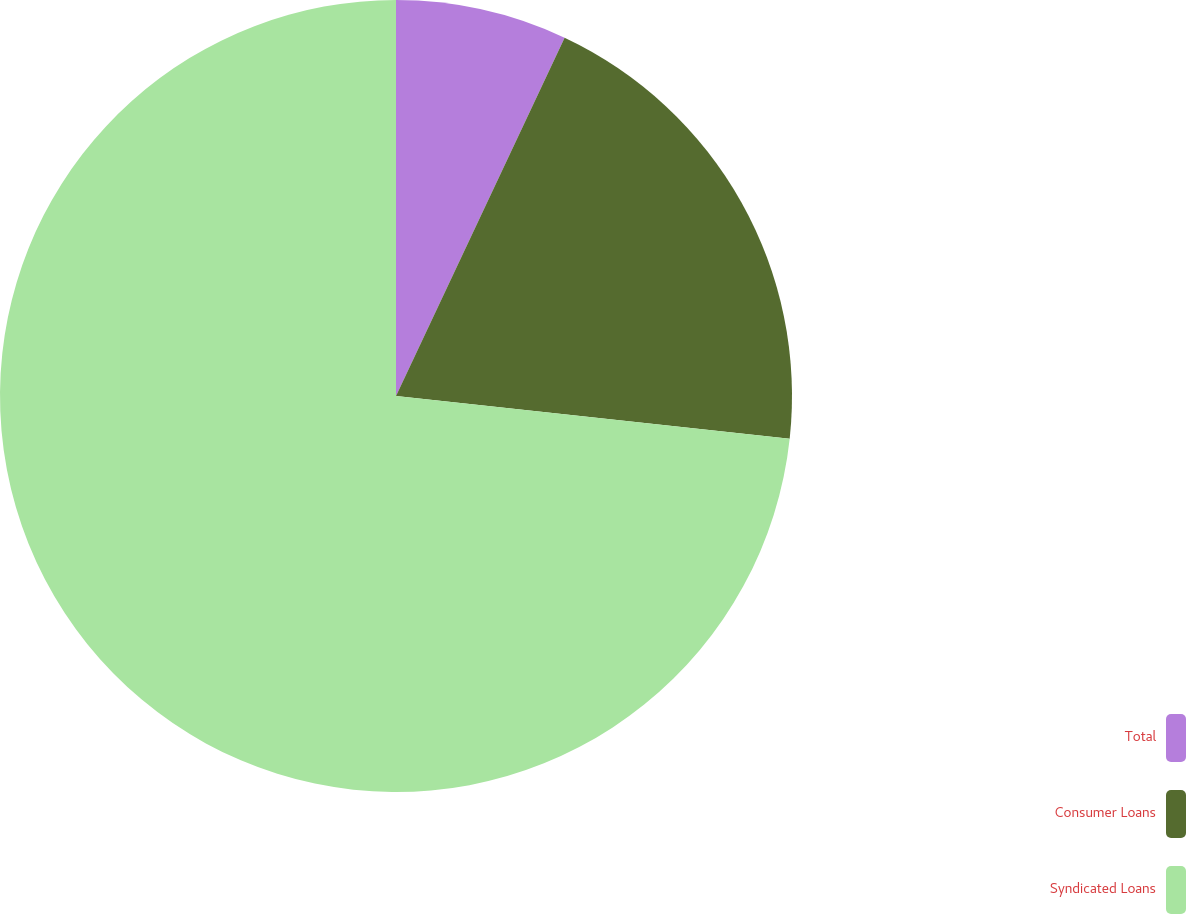Convert chart to OTSL. <chart><loc_0><loc_0><loc_500><loc_500><pie_chart><fcel>Total<fcel>Consumer Loans<fcel>Syndicated Loans<nl><fcel>7.0%<fcel>19.72%<fcel>73.28%<nl></chart> 